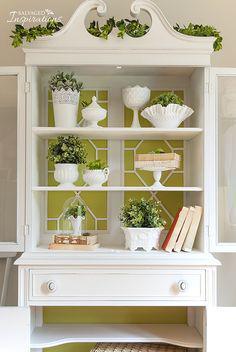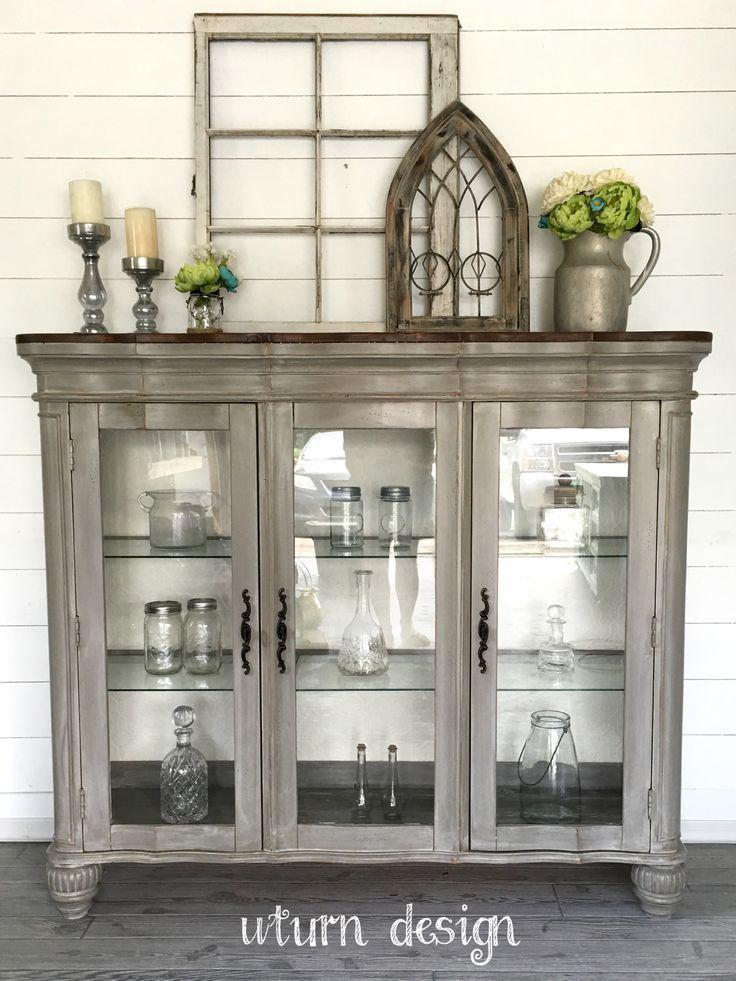The first image is the image on the left, the second image is the image on the right. For the images shown, is this caption "The white cabinet on the left has an ornate, curved top piece" true? Answer yes or no. Yes. The first image is the image on the left, the second image is the image on the right. Analyze the images presented: Is the assertion "The top of one cabinet is not flat, and features two curl shapes that face each other." valid? Answer yes or no. Yes. 